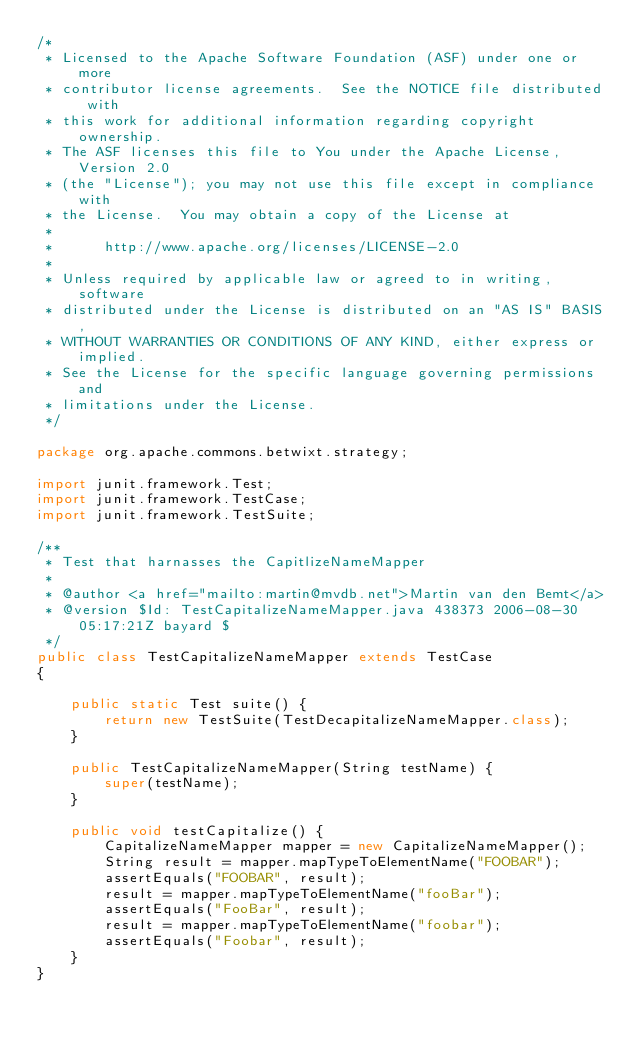Convert code to text. <code><loc_0><loc_0><loc_500><loc_500><_Java_>/*
 * Licensed to the Apache Software Foundation (ASF) under one or more
 * contributor license agreements.  See the NOTICE file distributed with
 * this work for additional information regarding copyright ownership.
 * The ASF licenses this file to You under the Apache License, Version 2.0
 * (the "License"); you may not use this file except in compliance with
 * the License.  You may obtain a copy of the License at
 * 
 *      http://www.apache.org/licenses/LICENSE-2.0
 * 
 * Unless required by applicable law or agreed to in writing, software
 * distributed under the License is distributed on an "AS IS" BASIS,
 * WITHOUT WARRANTIES OR CONDITIONS OF ANY KIND, either express or implied.
 * See the License for the specific language governing permissions and
 * limitations under the License.
 */ 
 
package org.apache.commons.betwixt.strategy;

import junit.framework.Test;
import junit.framework.TestCase;
import junit.framework.TestSuite;

/**
 * Test that harnasses the CapitlizeNameMapper
 * 
 * @author <a href="mailto:martin@mvdb.net">Martin van den Bemt</a>
 * @version $Id: TestCapitalizeNameMapper.java 438373 2006-08-30 05:17:21Z bayard $
 */
public class TestCapitalizeNameMapper extends TestCase
{

    public static Test suite() {
        return new TestSuite(TestDecapitalizeNameMapper.class);
    }
    
    public TestCapitalizeNameMapper(String testName) {
        super(testName);
    }
    
    public void testCapitalize() {
        CapitalizeNameMapper mapper = new CapitalizeNameMapper();
        String result = mapper.mapTypeToElementName("FOOBAR");
        assertEquals("FOOBAR", result);
        result = mapper.mapTypeToElementName("fooBar");
        assertEquals("FooBar", result);
        result = mapper.mapTypeToElementName("foobar");
        assertEquals("Foobar", result);
    }
}


</code> 